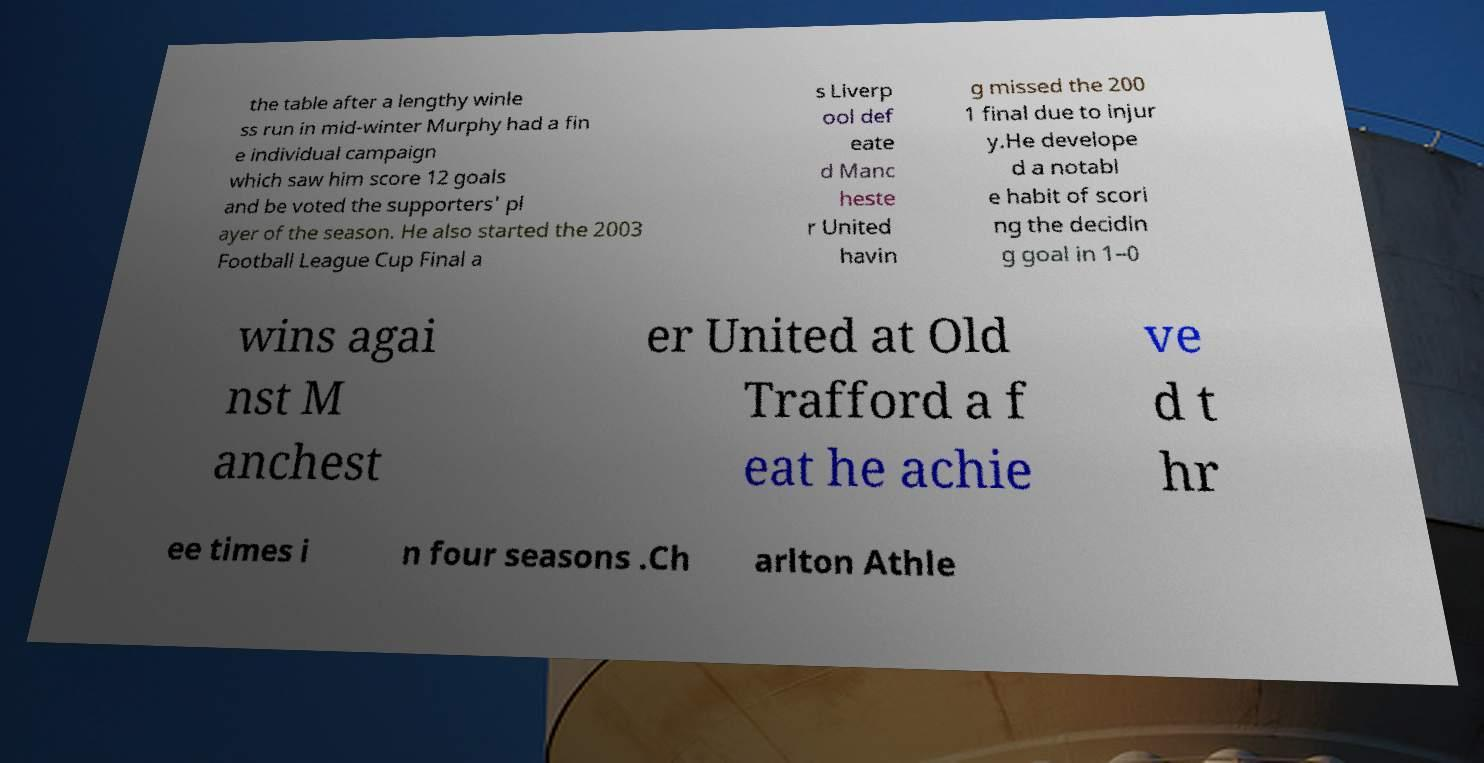Please read and relay the text visible in this image. What does it say? the table after a lengthy winle ss run in mid-winter Murphy had a fin e individual campaign which saw him score 12 goals and be voted the supporters' pl ayer of the season. He also started the 2003 Football League Cup Final a s Liverp ool def eate d Manc heste r United havin g missed the 200 1 final due to injur y.He develope d a notabl e habit of scori ng the decidin g goal in 1–0 wins agai nst M anchest er United at Old Trafford a f eat he achie ve d t hr ee times i n four seasons .Ch arlton Athle 